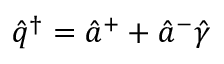<formula> <loc_0><loc_0><loc_500><loc_500>\hat { q } ^ { \dagger } = \hat { a } ^ { + } + \hat { a } ^ { - } \hat { \gamma }</formula> 